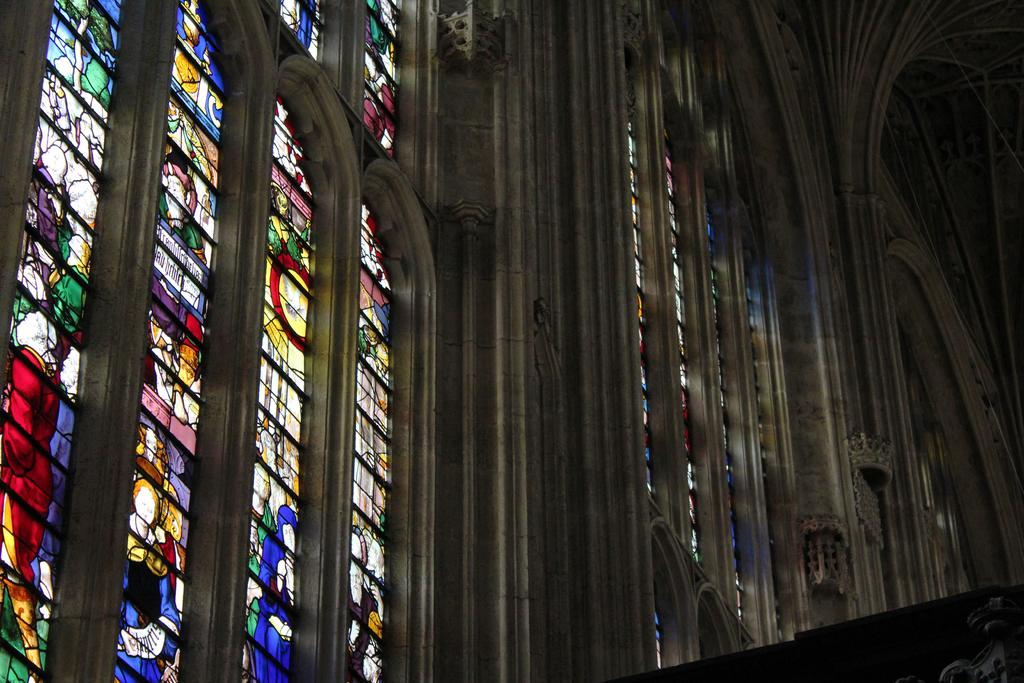What type of architectural feature can be seen in the image? There are walls with arches in the image. What other design elements are present in the image? There are pillars with designs in the image. What objects have designs on them in the image? There are glasses with designs in the image. What is depicted on the glasses in the image? There are images on the glasses in the image. What type of pet can be seen playing with a pencil in the image? There is no pet or pencil present in the image. 